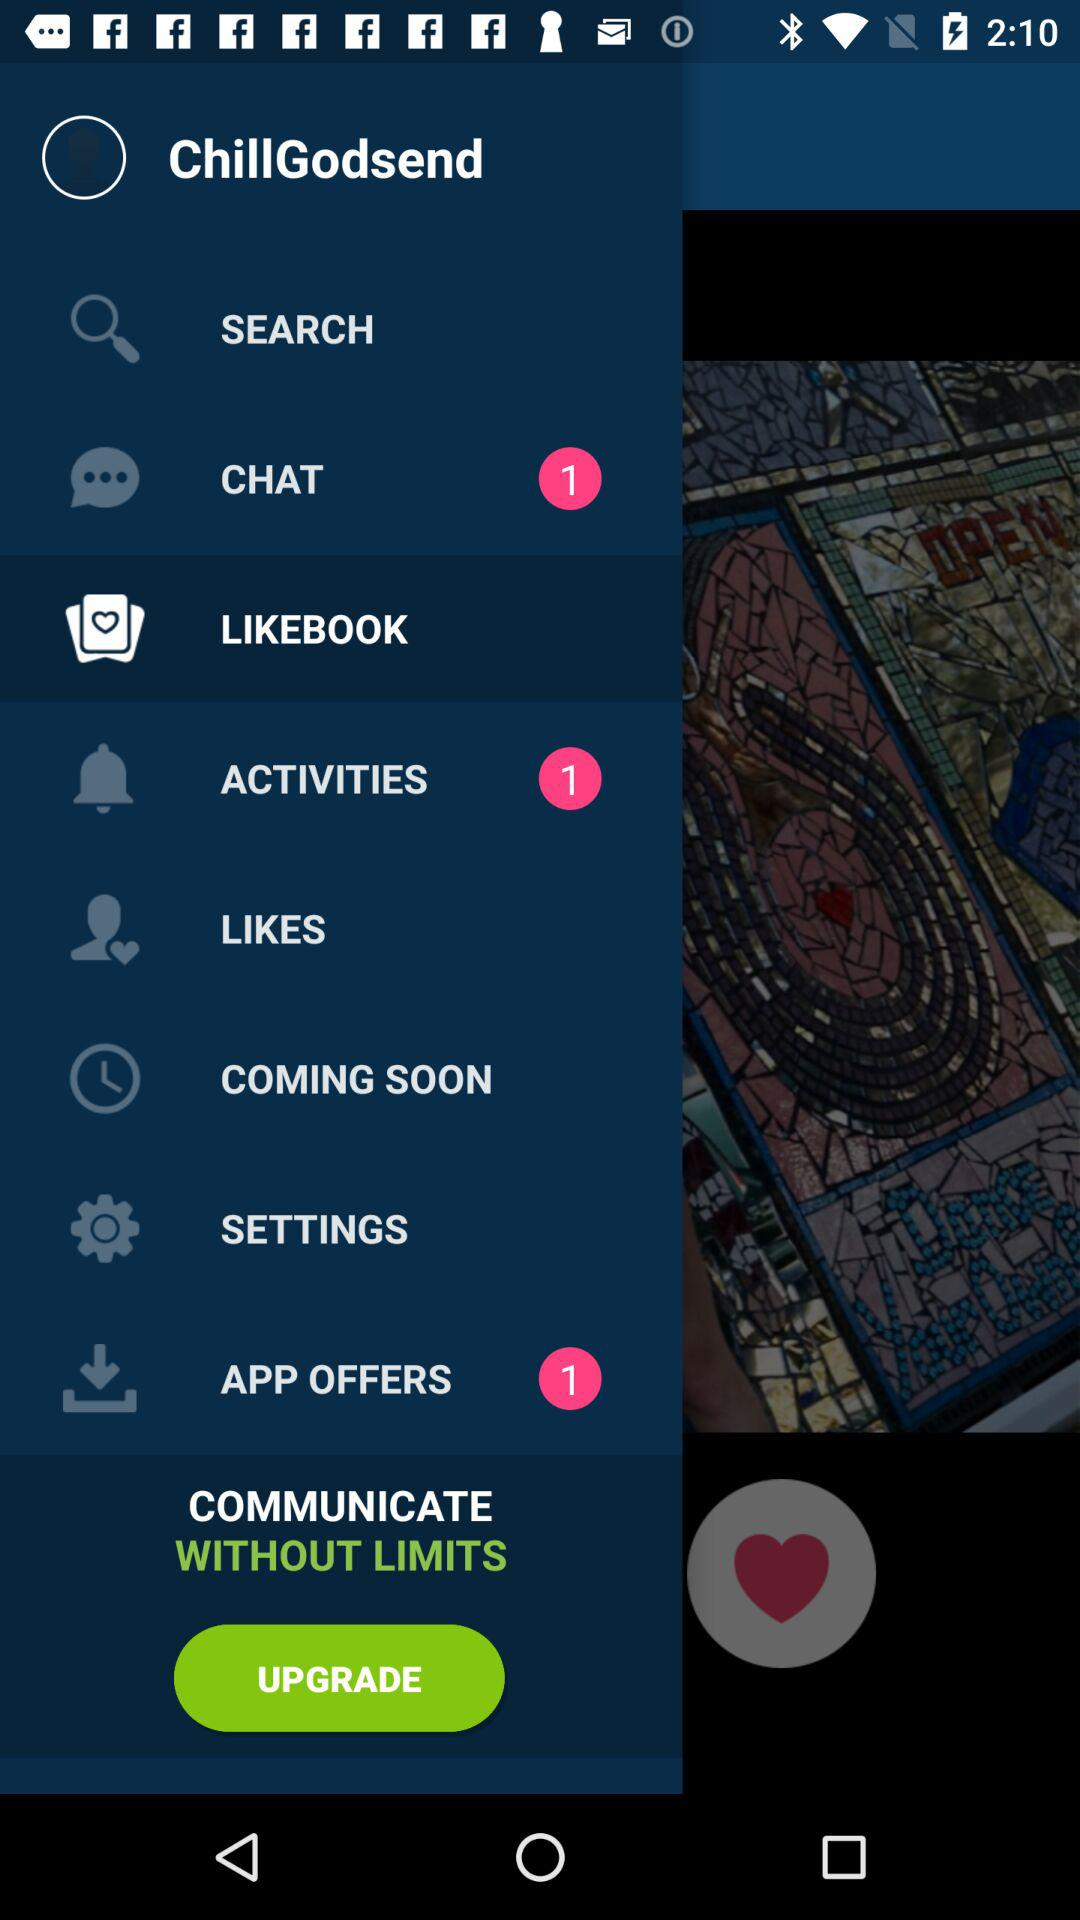Which item is selected in the menu? The selected item in the menu is "LIKEBOOK". 